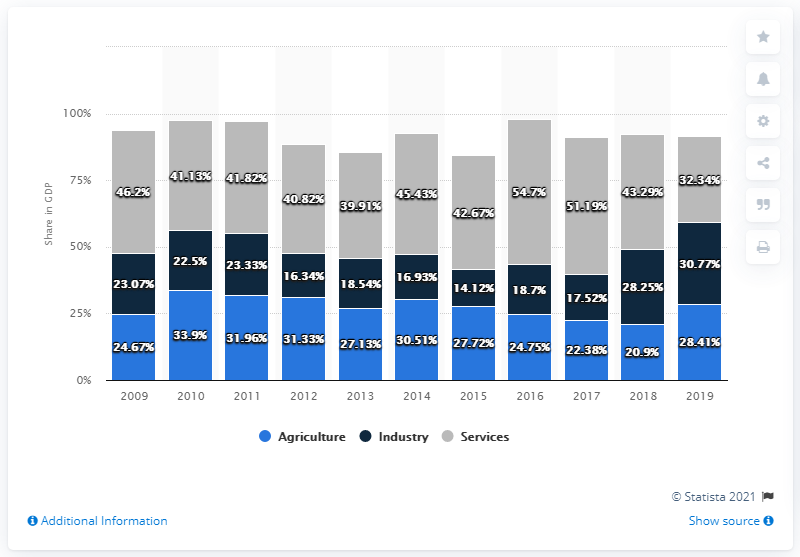Give some essential details in this illustration. The difference between the highest percentage for the service sector and the lowest was 22.36%. The services sector had the highest percentage at 54.7%. 